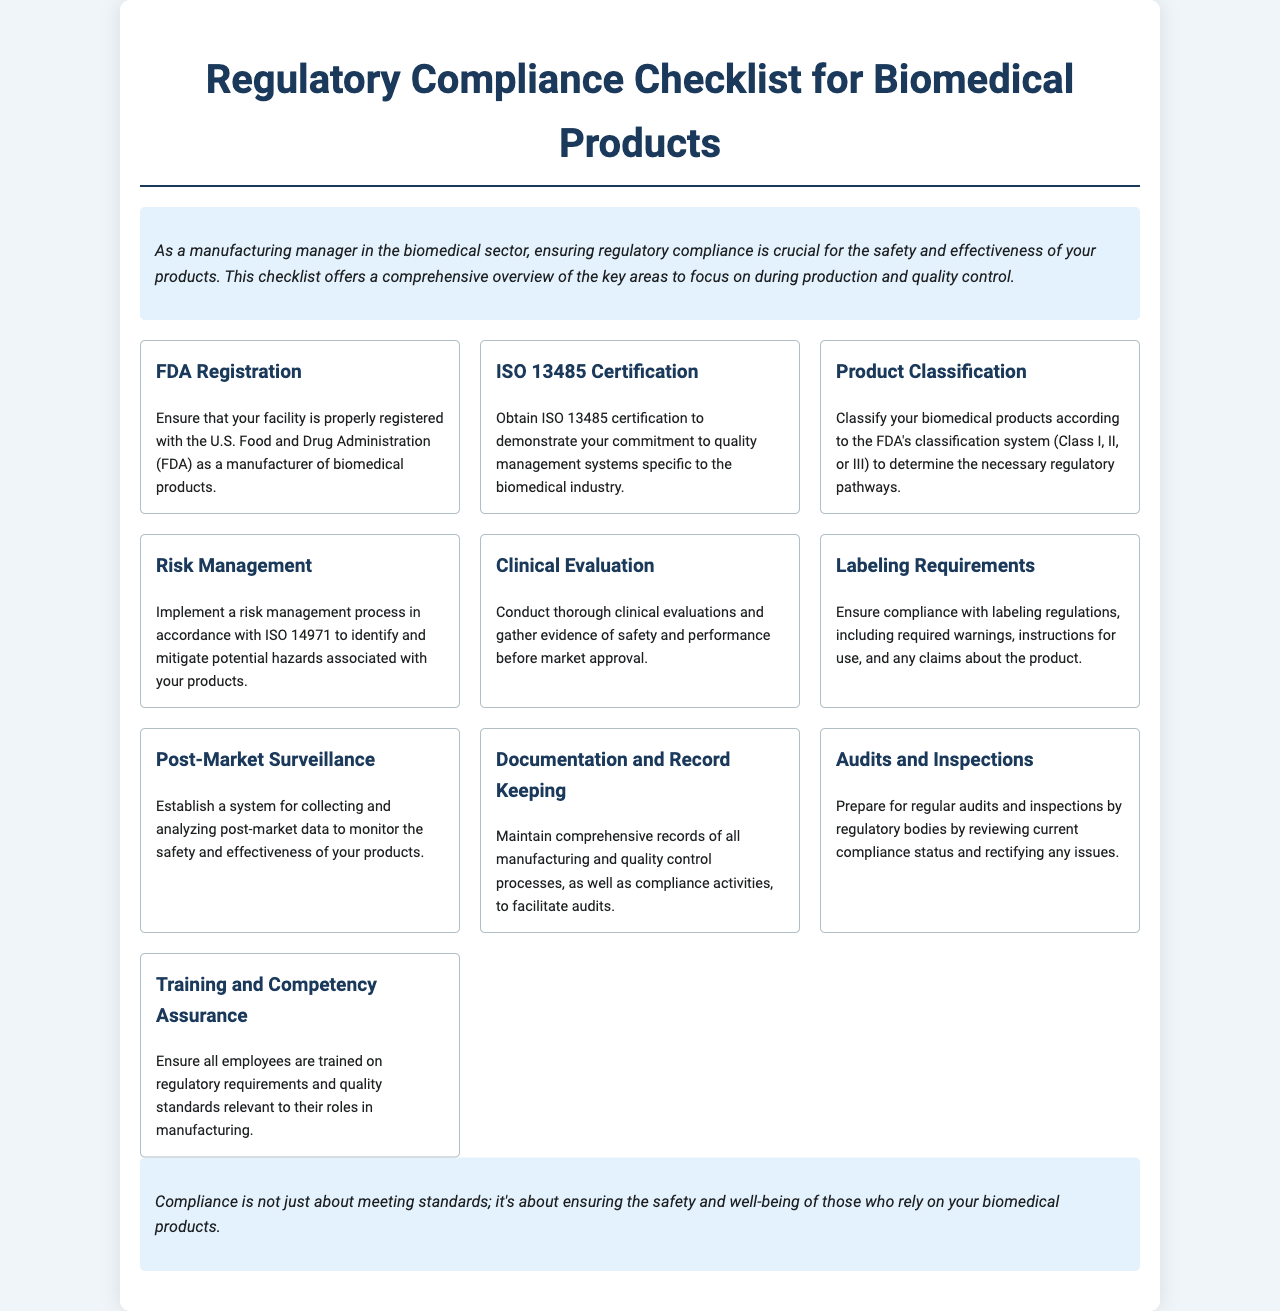What is the main purpose of the checklist? The checklist offers a comprehensive overview of the key areas to focus on during production and quality control in the biomedical sector.
Answer: Key areas What certification is required for quality management systems? The document states that obtaining ISO 13485 certification demonstrates a commitment to quality management systems specific to the biomedical industry.
Answer: ISO 13485 Which regulatory body is mentioned for facility registration? The document mentions the U.S. Food and Drug Administration (FDA) for proper registration as a manufacturer of biomedical products.
Answer: FDA What is the focus of the risk management process? The risk management process must be implemented in accordance with ISO 14971 to identify and mitigate potential hazards associated with products.
Answer: Hazards What must be maintained for compliance activities? The document highlights the necessity to maintain comprehensive records of all manufacturing and quality control processes.
Answer: Comprehensive records How often should audits and inspections be prepared for? Regular audits and inspections by regulatory bodies should be prepared for according to the document.
Answer: Regularly What is essential for employee training? Ensuring all employees are trained on regulatory requirements and quality standards is essential, as per the document.
Answer: Training What does post-market surveillance monitor? The document states that a system for collecting and analyzing post-market data is to monitor the safety and effectiveness of products.
Answer: Safety and effectiveness What type of document is this? The document is a brochure that provides a checklist for regulatory compliance in the biomedical industry.
Answer: Brochure 